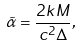Convert formula to latex. <formula><loc_0><loc_0><loc_500><loc_500>\tilde { \alpha } = \frac { 2 k M } { c ^ { 2 } \Delta } ,</formula> 